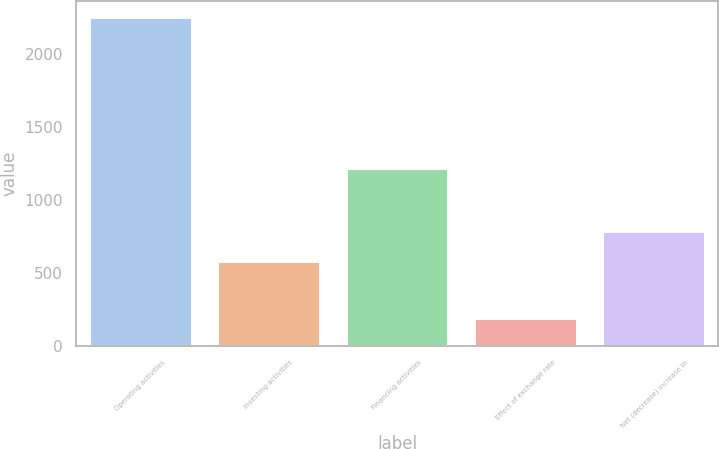Convert chart. <chart><loc_0><loc_0><loc_500><loc_500><bar_chart><fcel>Operating activities<fcel>Investing activities<fcel>Financing activities<fcel>Effect of exchange rate<fcel>Net (decrease) increase in<nl><fcel>2253<fcel>584<fcel>1223<fcel>190<fcel>790.3<nl></chart> 